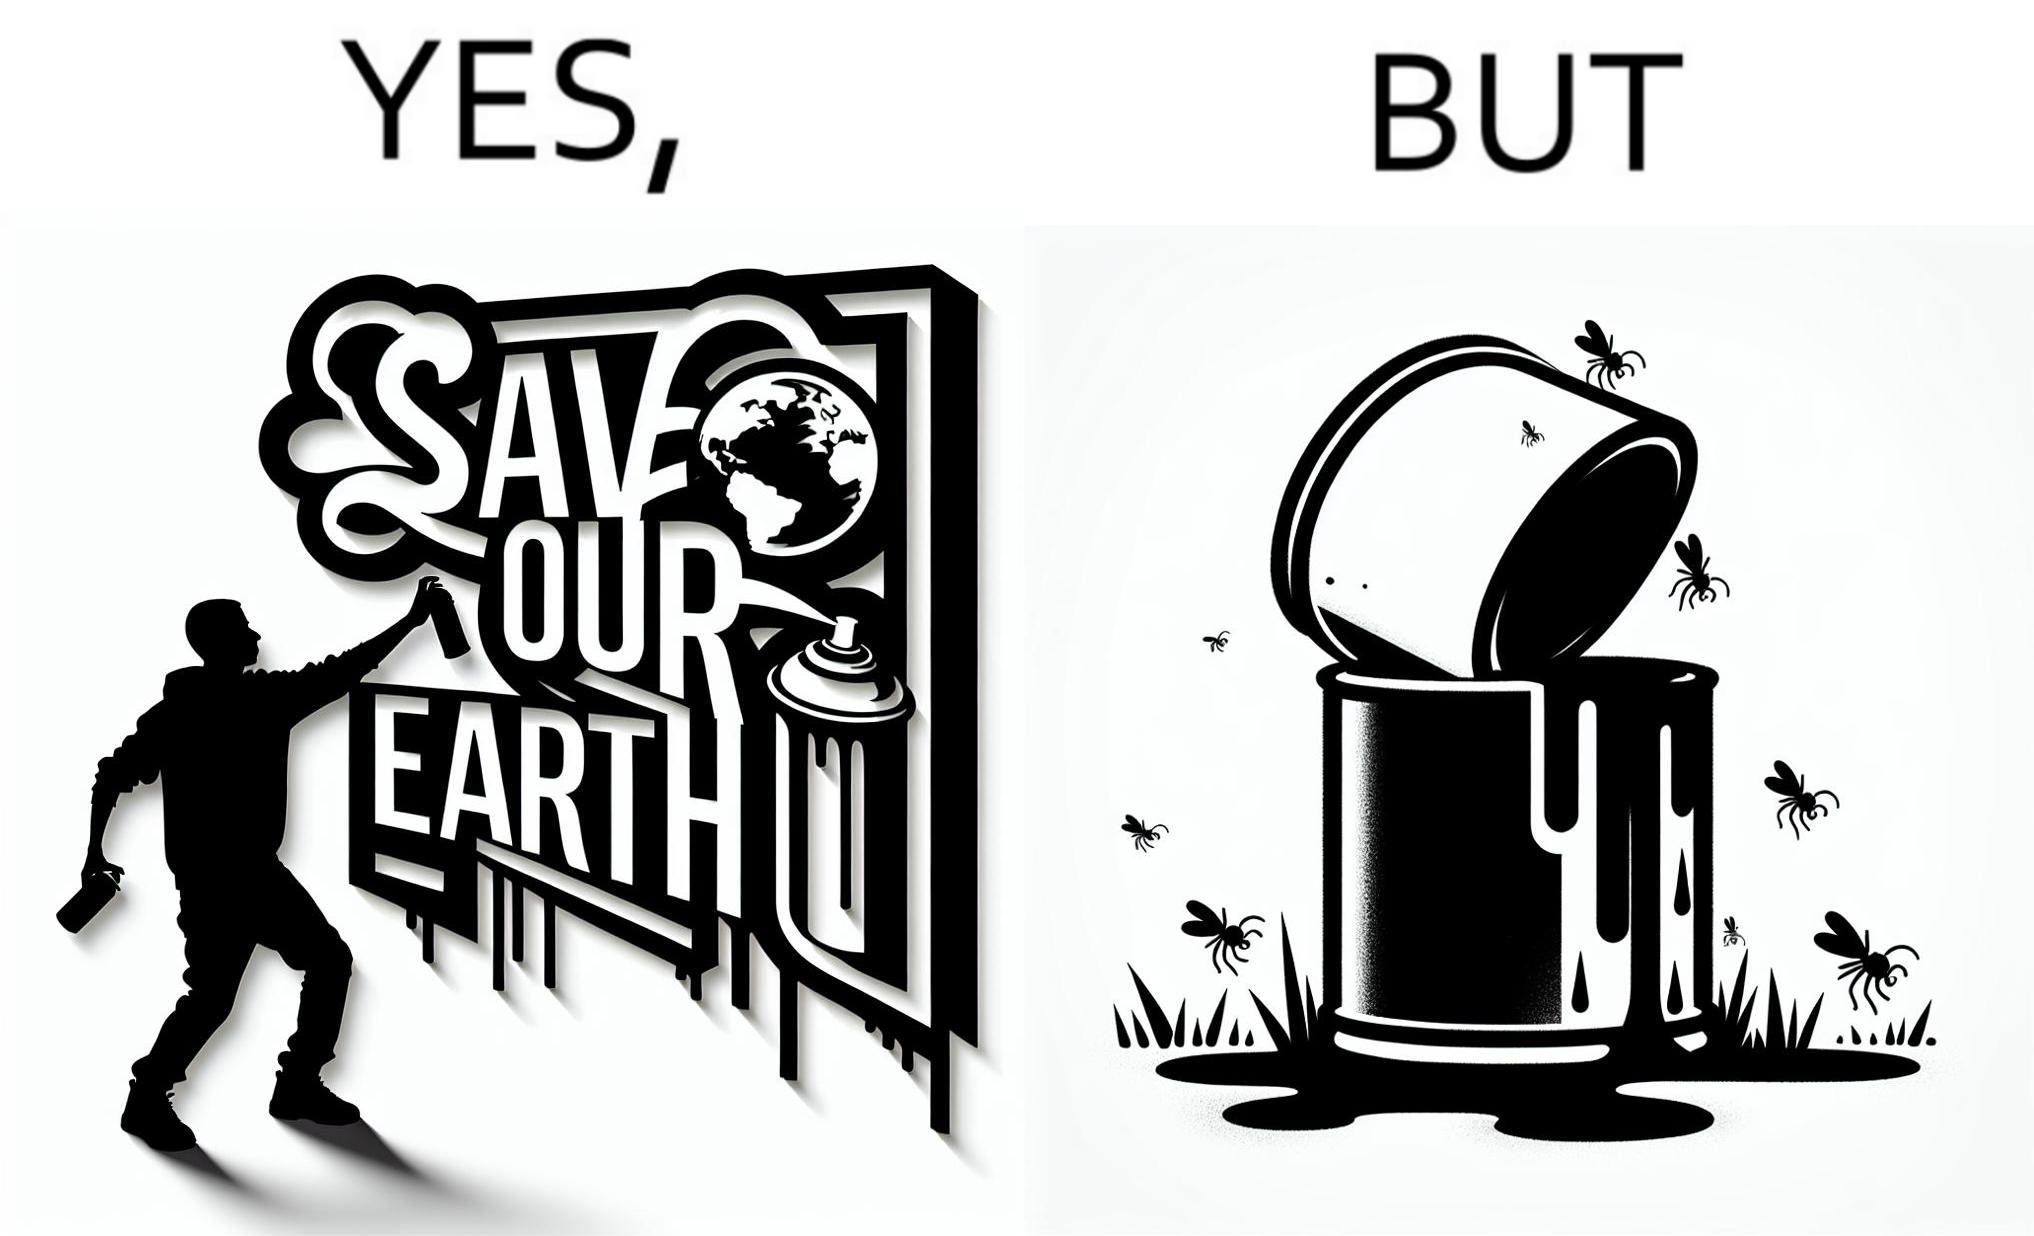Is this image satirical or non-satirical? Yes, this image is satirical. 